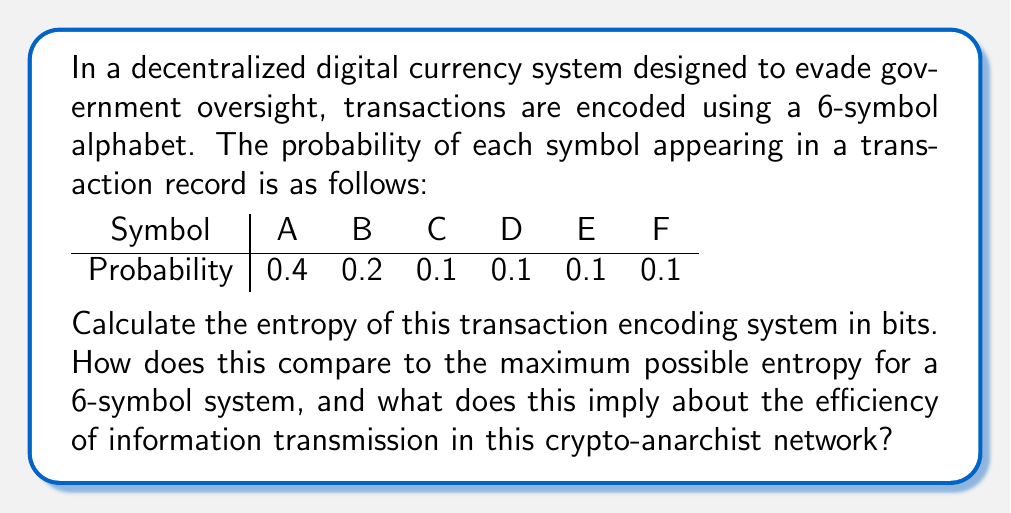Show me your answer to this math problem. To solve this problem, we'll follow these steps:

1) Calculate the entropy of the given system
2) Calculate the maximum possible entropy for a 6-symbol system
3) Compare the two and interpret the results

Step 1: Calculating the entropy of the given system

The entropy of a discrete random variable X is given by the formula:

$$ H(X) = -\sum_{i=1}^{n} p(x_i) \log_2 p(x_i) $$

Where $p(x_i)$ is the probability of the i-th symbol.

Let's calculate each term:

$$ \begin{align*}
-0.4 \log_2 0.4 &= 0.528771 \\
-0.2 \log_2 0.2 &= 0.464386 \\
-0.1 \log_2 0.1 &= 0.332193 \\
-0.1 \log_2 0.1 &= 0.332193 \\
-0.1 \log_2 0.1 &= 0.332193 \\
-0.1 \log_2 0.1 &= 0.332193 \\
\end{align*} $$

Sum these values:

$$ H(X) = 0.528771 + 0.464386 + 4(0.332193) = 2.321929 \text{ bits} $$

Step 2: Calculating the maximum possible entropy

The maximum entropy occurs when all symbols are equally likely. For a 6-symbol system, this means each symbol has a probability of 1/6.

$$ H_{max} = -\sum_{i=1}^{6} \frac{1}{6} \log_2 \frac{1}{6} = -6 \cdot \frac{1}{6} \log_2 \frac{1}{6} = \log_2 6 \approx 2.584963 \text{ bits} $$

Step 3: Comparison and interpretation

The entropy of our system (2.321929 bits) is about 89.8% of the maximum possible entropy (2.584963 bits). This indicates that the system is reasonably efficient in terms of information transmission, but there's still some redundancy.

In the context of a crypto-anarchist network, this level of efficiency suggests a good balance between compression (which aids in evading detection and reducing transmission costs) and redundancy (which can help with error correction in a potentially noisy or adversarial channel). The slight inefficiency might be a deliberate design choice to increase robustness against government attempts to disrupt or decrypt the transactions.
Answer: The entropy of the given transaction encoding system is approximately 2.321929 bits. This is about 89.8% of the maximum possible entropy for a 6-symbol system (2.584963 bits), indicating a relatively efficient information transmission system with some built-in redundancy, likely for error correction and robustness against interference. 